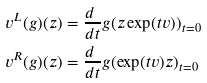Convert formula to latex. <formula><loc_0><loc_0><loc_500><loc_500>v ^ { L } ( g ) ( z ) & = \frac { d \ } { d t } g ( z \exp ( t v ) ) _ { t = 0 } \\ v ^ { R } ( g ) ( z ) & = \frac { d \ } { d t } g ( \exp ( t v ) z ) _ { t = 0 }</formula> 